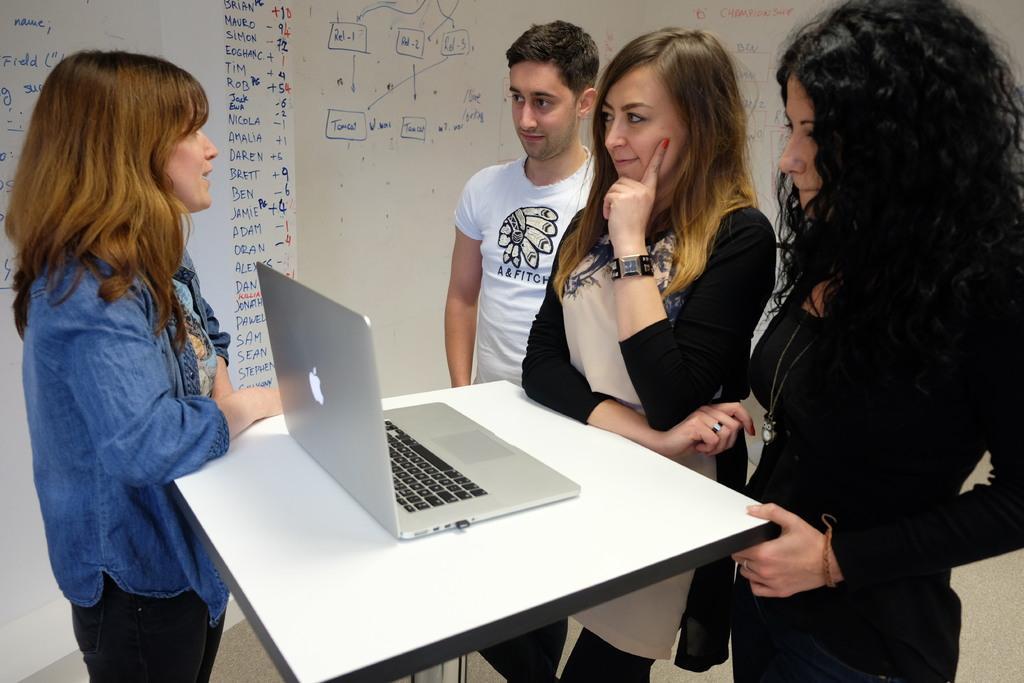Describe this image in one or two sentences. As we can see in the image, there are four persons standing around table. On table there is a laptop and here there is a white color board. 